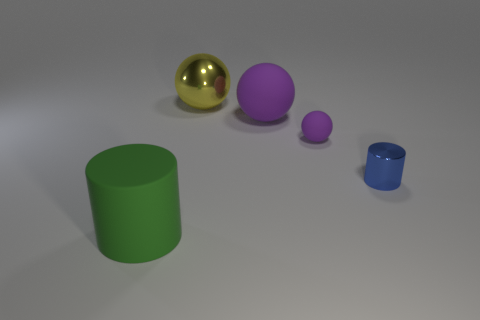Add 3 small green cylinders. How many objects exist? 8 Subtract all big yellow things. Subtract all tiny brown cylinders. How many objects are left? 4 Add 2 yellow shiny spheres. How many yellow shiny spheres are left? 3 Add 3 big purple spheres. How many big purple spheres exist? 4 Subtract all purple spheres. How many spheres are left? 1 Subtract all tiny matte spheres. How many spheres are left? 2 Subtract 2 purple balls. How many objects are left? 3 Subtract all cylinders. How many objects are left? 3 Subtract 1 spheres. How many spheres are left? 2 Subtract all cyan balls. Subtract all gray cylinders. How many balls are left? 3 